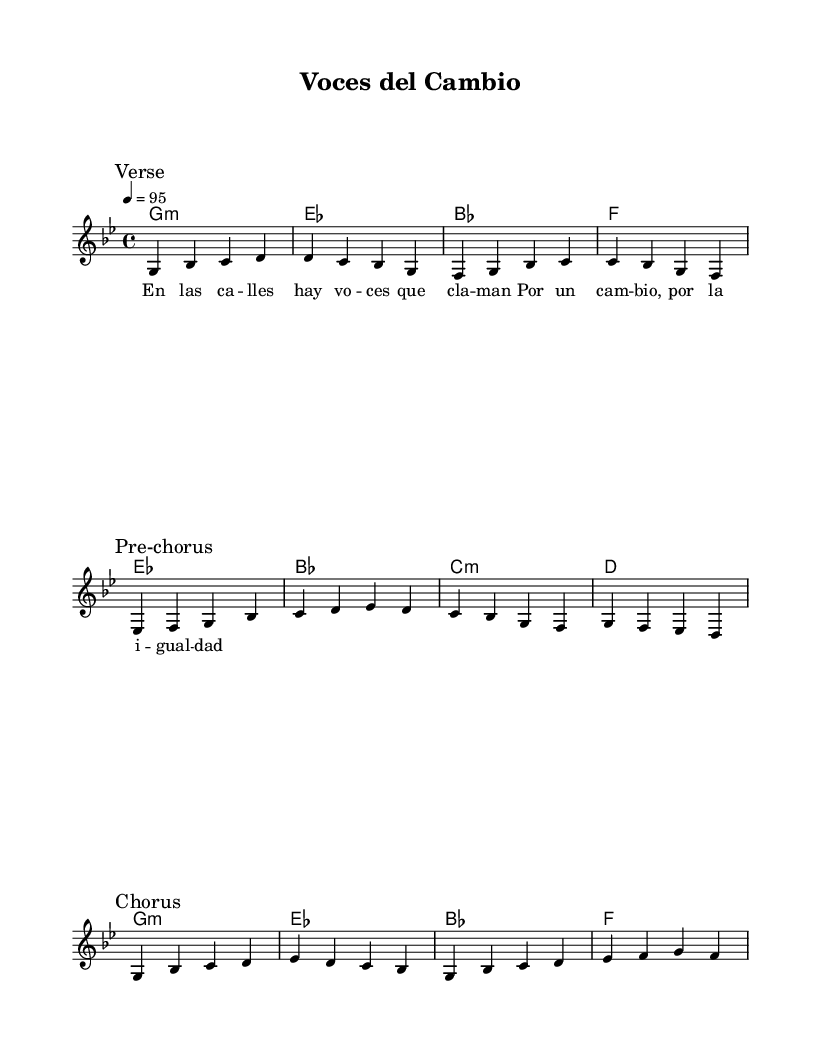What is the key signature of this music? The key signature is indicated at the beginning of the staff. It is G minor, which contains two flats (B flat and E flat).
Answer: G minor What is the time signature of this music? The time signature is written near the beginning of the score. It displays a 4 over 4, indicating a common time signature.
Answer: 4/4 What is the tempo marking for this piece? The tempo is indicated in the header with a number and a note value. It shows a tempo of 95 beats per minute.
Answer: 95 How many sections are there in the melody? The melody is divided into three distinct sections: Verse, Pre-chorus, and Chorus, each marked accordingly.
Answer: Three What chords are used in the first verse? The harmonies for the first verse include G minor, E flat, B flat, and F, as provided in the chord section.
Answer: G minor, E flat, B flat, F What is the theme of the lyrics? The lyrics express a call for change and equality within society, reflecting social consciousness. This message is conveyed through phrases in the verse.
Answer: Change and equality What is the style of this music based on the lyrics? The lyrics are interconnected with themes of social awareness and activism, which is characteristic of modern reggaeton that often reflects societal issues.
Answer: Reggaeton with social consciousness 